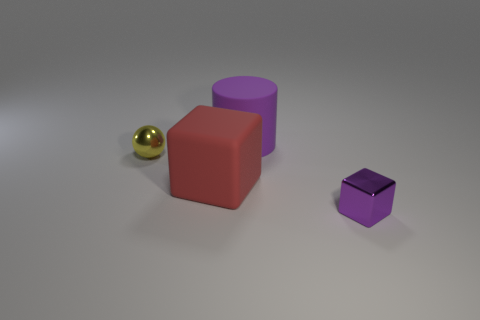Add 3 large matte cylinders. How many objects exist? 7 Subtract all cylinders. How many objects are left? 3 Subtract 0 green cylinders. How many objects are left? 4 Subtract all cubes. Subtract all balls. How many objects are left? 1 Add 1 big purple rubber things. How many big purple rubber things are left? 2 Add 2 large brown matte cylinders. How many large brown matte cylinders exist? 2 